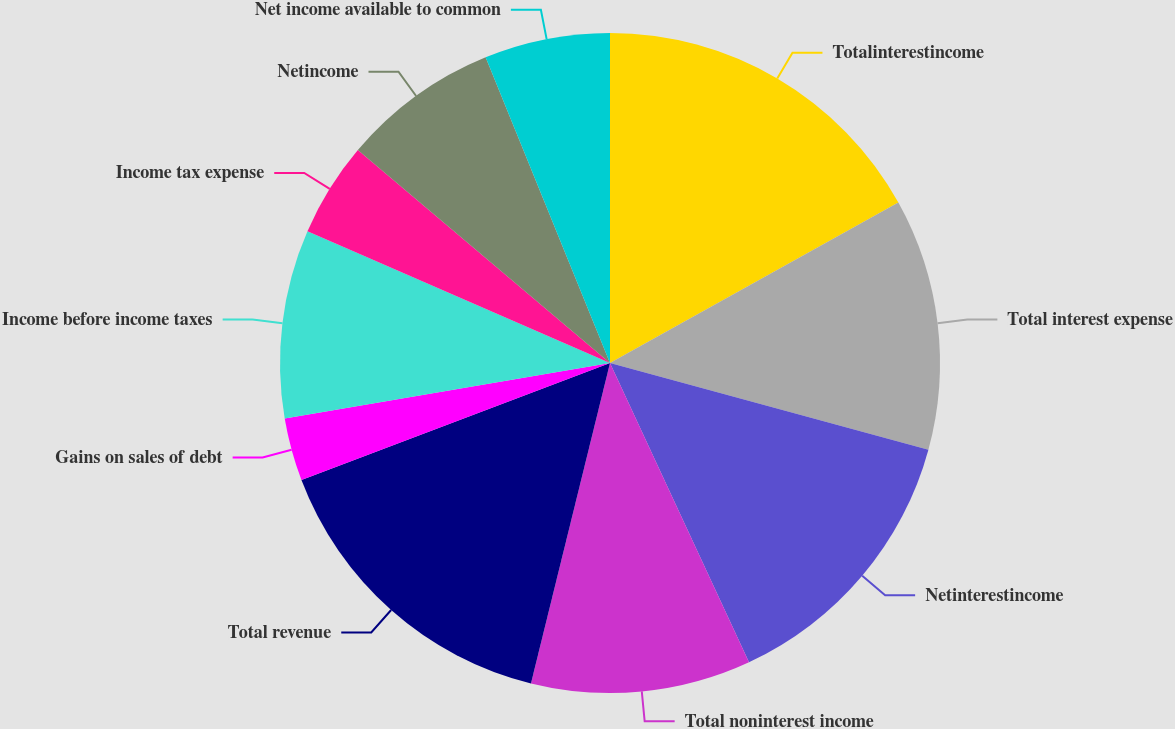Convert chart. <chart><loc_0><loc_0><loc_500><loc_500><pie_chart><fcel>Totalinterestincome<fcel>Total interest expense<fcel>Netinterestincome<fcel>Total noninterest income<fcel>Total revenue<fcel>Gains on sales of debt<fcel>Income before income taxes<fcel>Income tax expense<fcel>Netincome<fcel>Net income available to common<nl><fcel>16.92%<fcel>12.31%<fcel>13.85%<fcel>10.77%<fcel>15.38%<fcel>3.08%<fcel>9.23%<fcel>4.62%<fcel>7.69%<fcel>6.15%<nl></chart> 